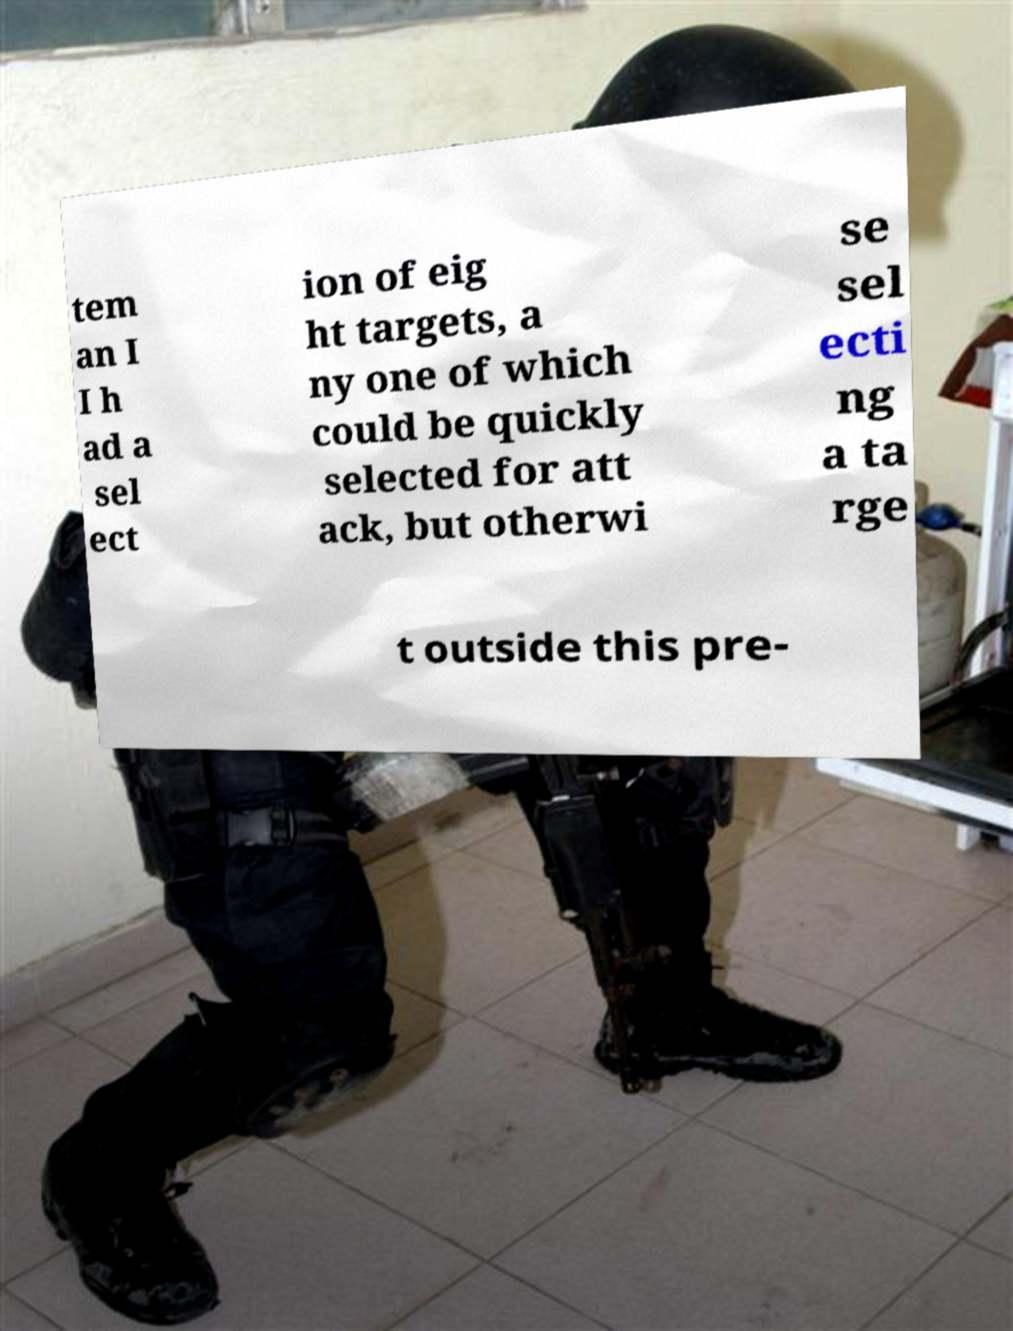For documentation purposes, I need the text within this image transcribed. Could you provide that? tem an I I h ad a sel ect ion of eig ht targets, a ny one of which could be quickly selected for att ack, but otherwi se sel ecti ng a ta rge t outside this pre- 